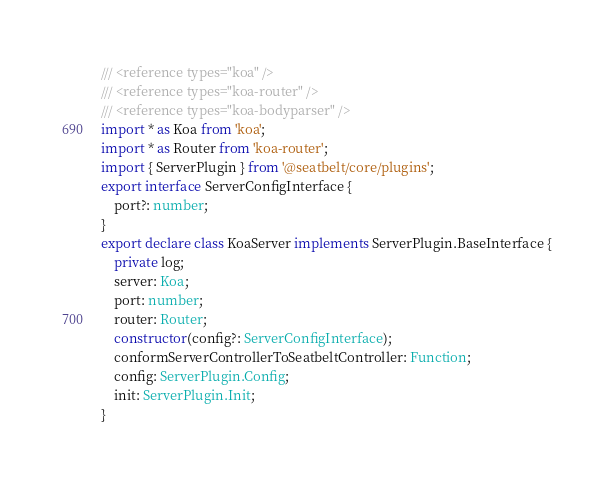<code> <loc_0><loc_0><loc_500><loc_500><_TypeScript_>/// <reference types="koa" />
/// <reference types="koa-router" />
/// <reference types="koa-bodyparser" />
import * as Koa from 'koa';
import * as Router from 'koa-router';
import { ServerPlugin } from '@seatbelt/core/plugins';
export interface ServerConfigInterface {
    port?: number;
}
export declare class KoaServer implements ServerPlugin.BaseInterface {
    private log;
    server: Koa;
    port: number;
    router: Router;
    constructor(config?: ServerConfigInterface);
    conformServerControllerToSeatbeltController: Function;
    config: ServerPlugin.Config;
    init: ServerPlugin.Init;
}
</code> 